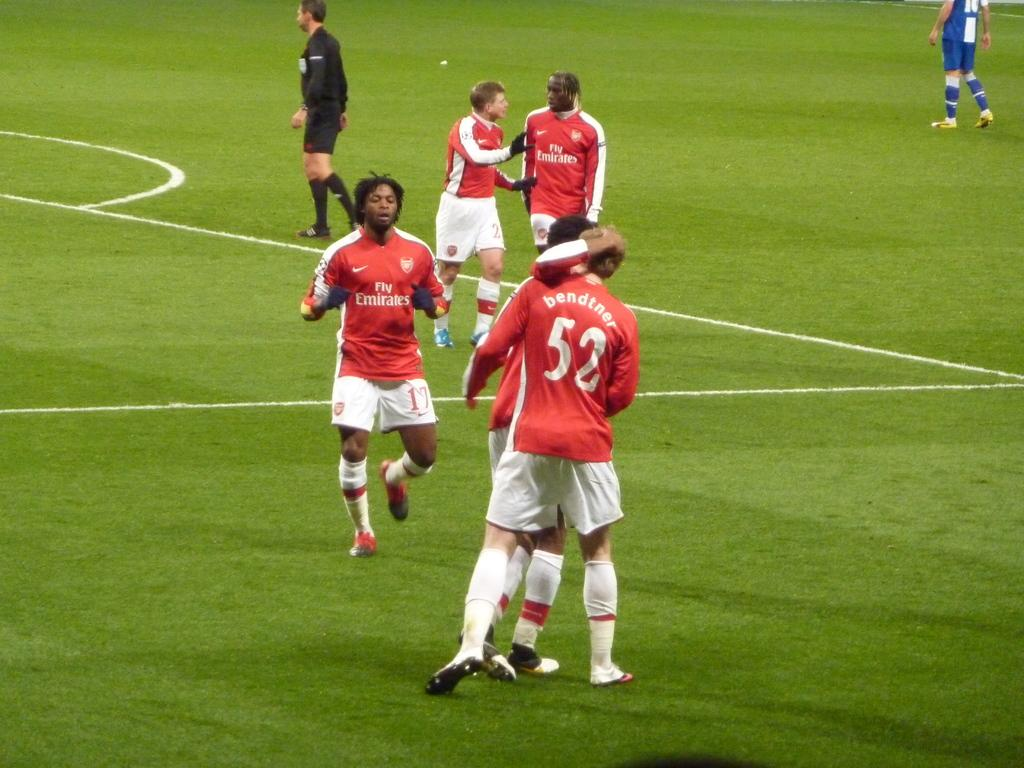<image>
Render a clear and concise summary of the photo. Soccer players are embracing on a soccer field with jerseys that say Fly Emirates. 